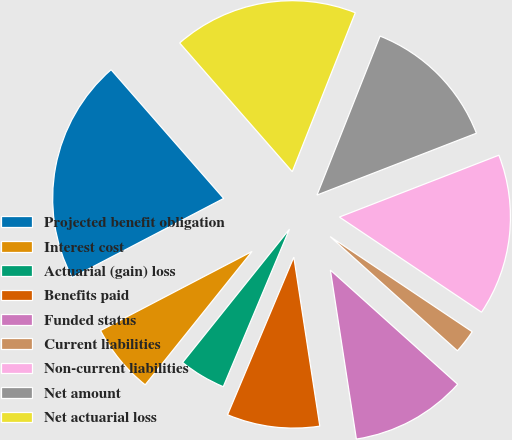<chart> <loc_0><loc_0><loc_500><loc_500><pie_chart><fcel>Projected benefit obligation<fcel>Interest cost<fcel>Actuarial (gain) loss<fcel>Benefits paid<fcel>Funded status<fcel>Current liabilities<fcel>Non-current liabilities<fcel>Net amount<fcel>Net actuarial loss<nl><fcel>21.22%<fcel>6.59%<fcel>4.42%<fcel>8.76%<fcel>10.93%<fcel>2.25%<fcel>15.28%<fcel>13.1%<fcel>17.45%<nl></chart> 